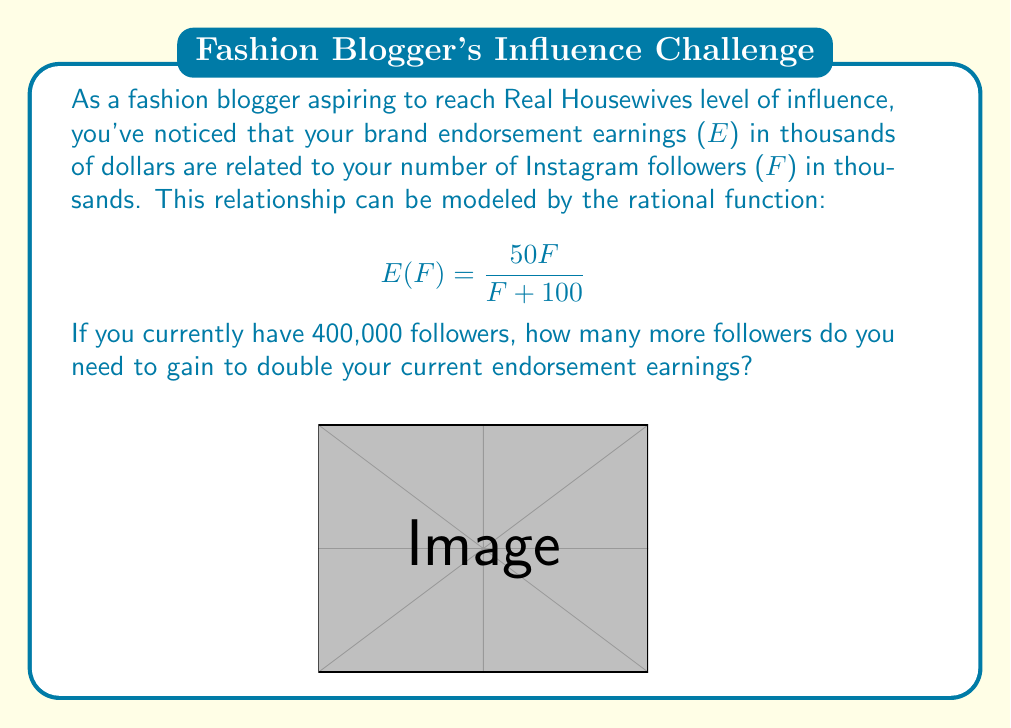Solve this math problem. Let's approach this step-by-step:

1) First, calculate your current earnings with 400,000 followers:
   $F = 400$ (in thousands)
   $$E(400) = \frac{50(400)}{400 + 100} = \frac{20000}{500} = 40$$
   So, your current earnings are $40,000.

2) To double your earnings, you need to find F where:
   $$E(F) = 2 * 40 = 80$$

3) Set up the equation:
   $$\frac{50F}{F + 100} = 80$$

4) Solve for F:
   $$50F = 80(F + 100)$$
   $$50F = 80F + 8000$$
   $$-30F = 8000$$
   $$F = -\frac{8000}{30} = -266.67$$

5) The negative solution doesn't make sense in this context, so we solve:
   $$F = \frac{8000}{30} = 266.67$$

6) This means you need 266,670 followers to double your earnings.

7) Calculate the difference:
   $266.67 - 400 = -133.33$ (in thousands)
   This negative value indicates you already have more than enough followers.

8) Therefore, you don't need to gain any more followers; you've already surpassed the number needed to double your earnings.
Answer: 0 followers (already exceeded) 